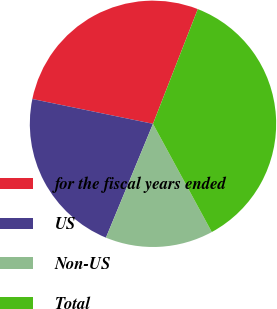Convert chart. <chart><loc_0><loc_0><loc_500><loc_500><pie_chart><fcel>for the fiscal years ended<fcel>US<fcel>Non-US<fcel>Total<nl><fcel>27.7%<fcel>21.99%<fcel>14.16%<fcel>36.15%<nl></chart> 